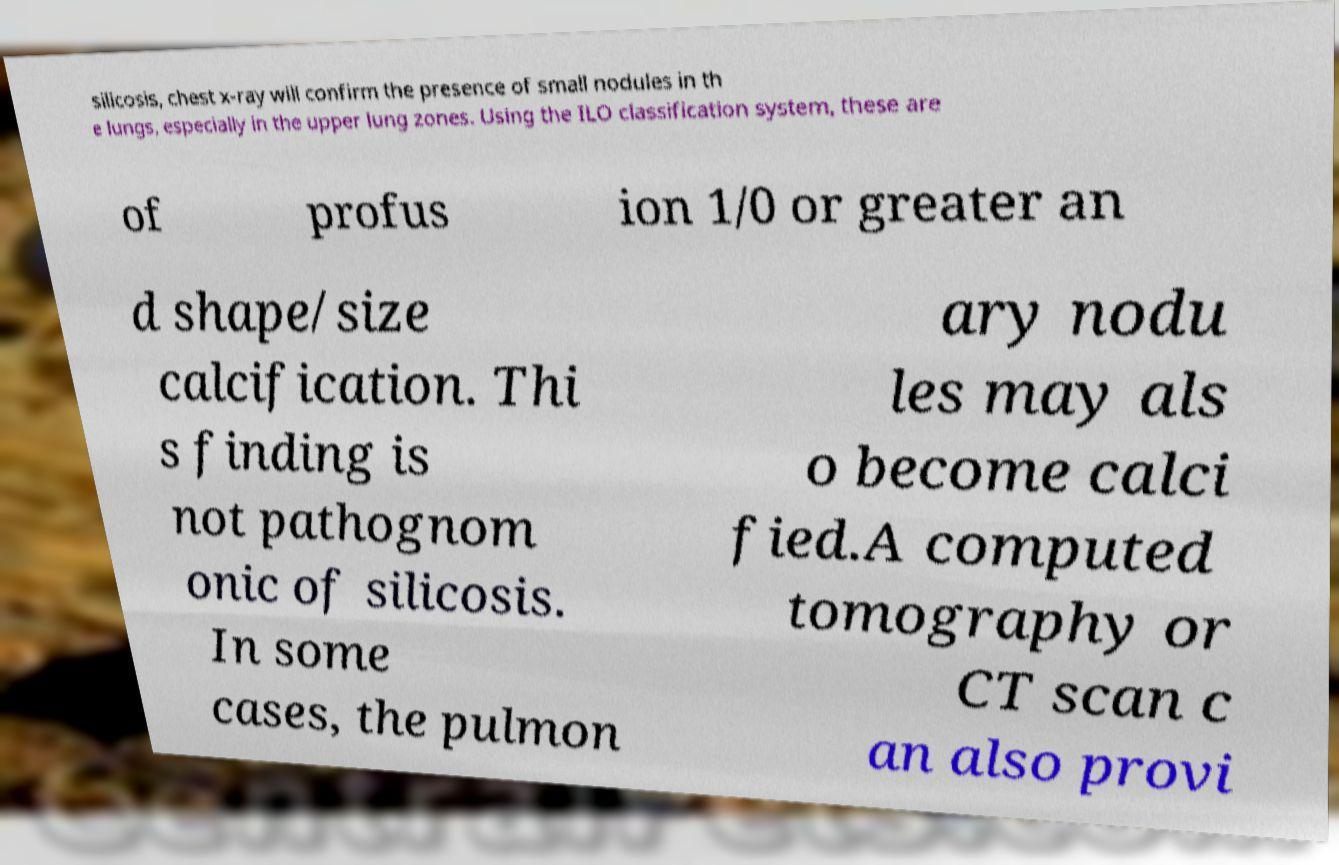There's text embedded in this image that I need extracted. Can you transcribe it verbatim? silicosis, chest x-ray will confirm the presence of small nodules in th e lungs, especially in the upper lung zones. Using the ILO classification system, these are of profus ion 1/0 or greater an d shape/size calcification. Thi s finding is not pathognom onic of silicosis. In some cases, the pulmon ary nodu les may als o become calci fied.A computed tomography or CT scan c an also provi 